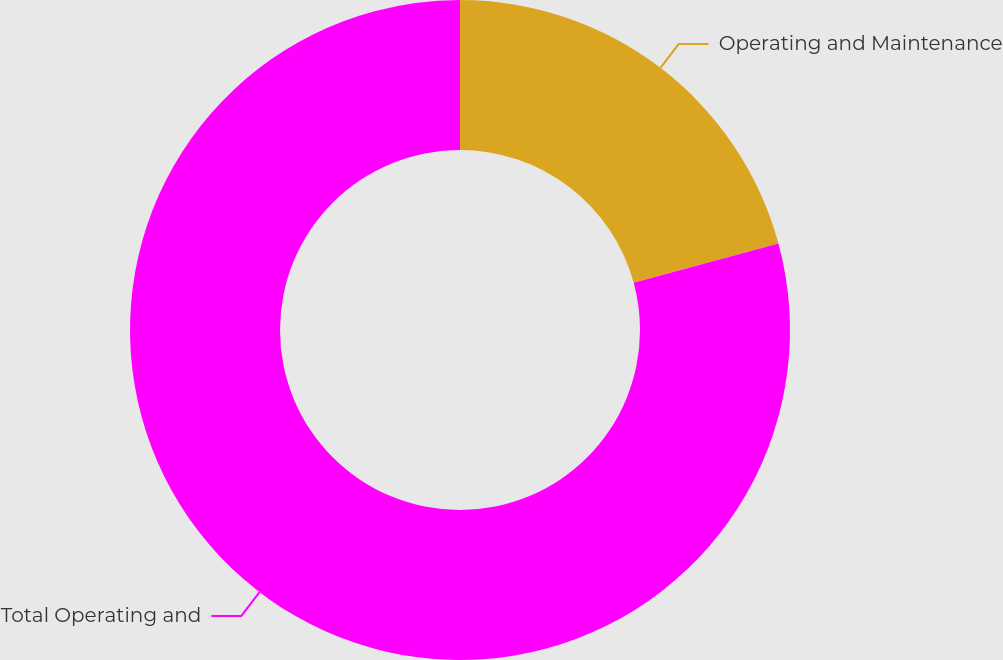Convert chart. <chart><loc_0><loc_0><loc_500><loc_500><pie_chart><fcel>Operating and Maintenance<fcel>Total Operating and<nl><fcel>20.78%<fcel>79.22%<nl></chart> 